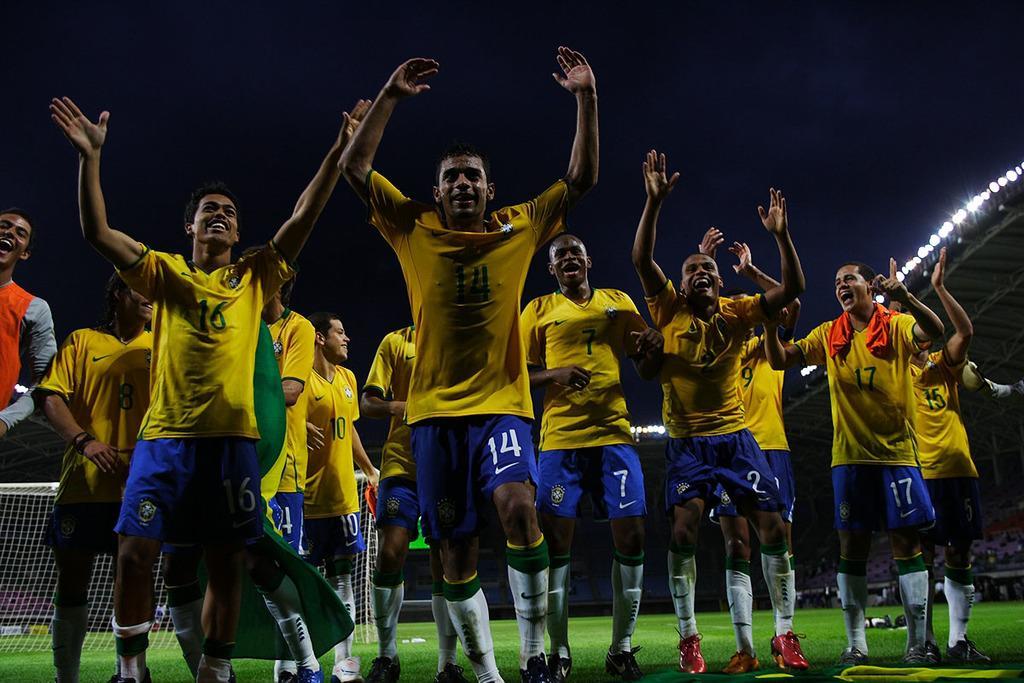Describe this image in one or two sentences. In this image I can see group of people standing, they are wearing yellow and blue color dress. Background I can see a net and few lights. 